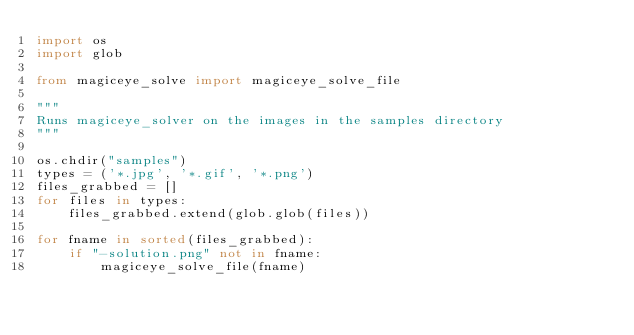<code> <loc_0><loc_0><loc_500><loc_500><_Python_>import os
import glob

from magiceye_solve import magiceye_solve_file

"""
Runs magiceye_solver on the images in the samples directory
"""

os.chdir("samples")
types = ('*.jpg', '*.gif', '*.png')
files_grabbed = []
for files in types:
    files_grabbed.extend(glob.glob(files))

for fname in sorted(files_grabbed):
    if "-solution.png" not in fname:
        magiceye_solve_file(fname)
</code> 